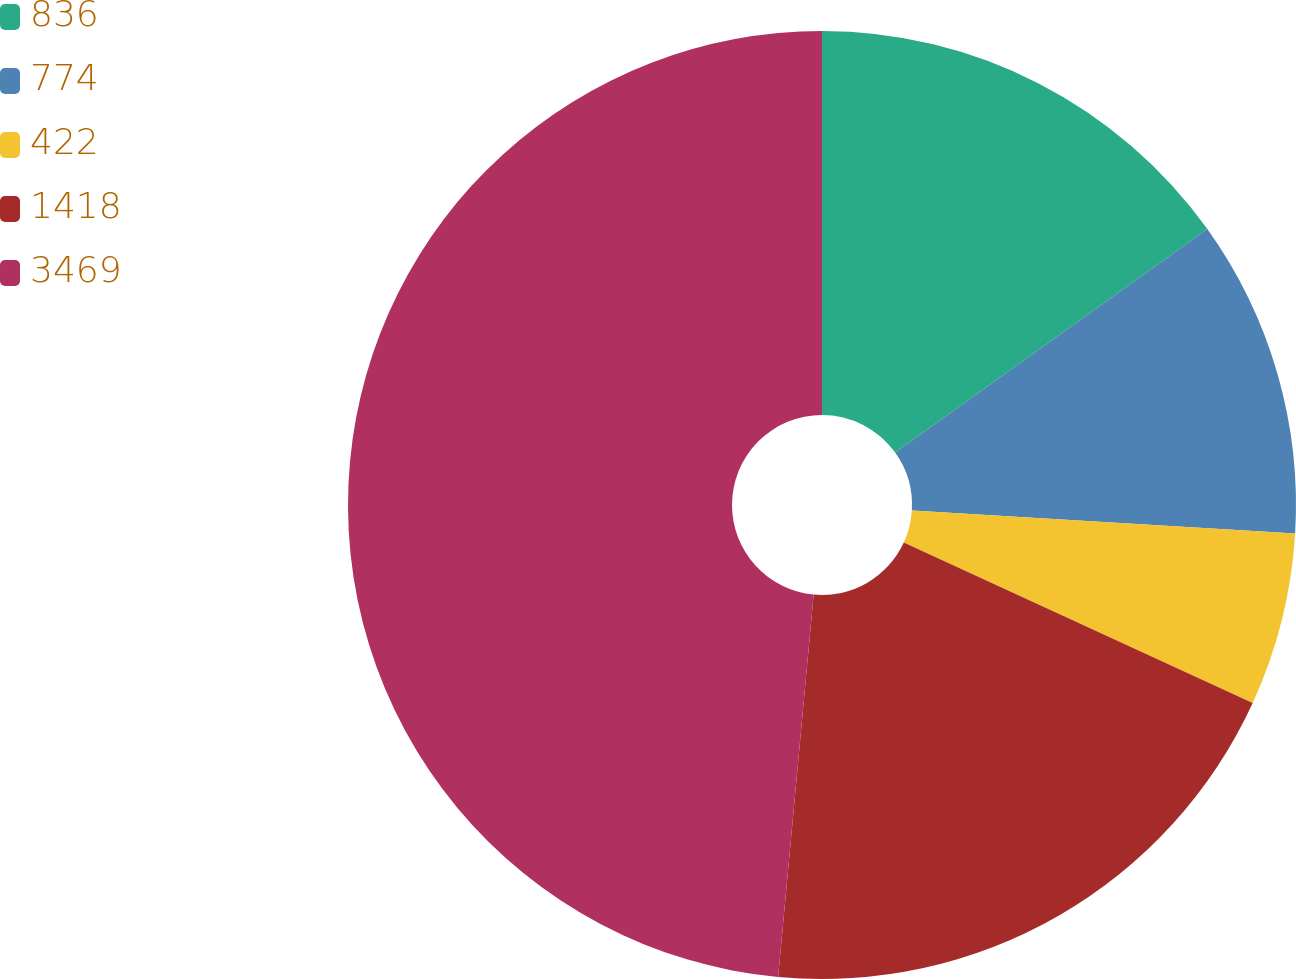Convert chart to OTSL. <chart><loc_0><loc_0><loc_500><loc_500><pie_chart><fcel>836<fcel>774<fcel>422<fcel>1418<fcel>3469<nl><fcel>15.11%<fcel>10.85%<fcel>5.9%<fcel>19.62%<fcel>48.53%<nl></chart> 